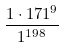<formula> <loc_0><loc_0><loc_500><loc_500>\frac { 1 \cdot 1 7 1 ^ { 9 } } { 1 ^ { 1 9 8 } }</formula> 